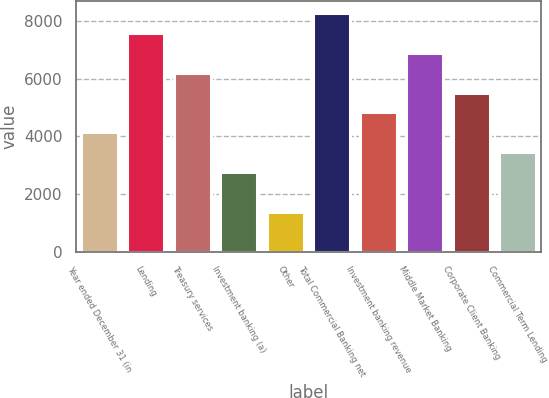Convert chart to OTSL. <chart><loc_0><loc_0><loc_500><loc_500><bar_chart><fcel>Year ended December 31 (in<fcel>Lending<fcel>Treasury services<fcel>Investment banking (a)<fcel>Other<fcel>Total Commercial Banking net<fcel>Investment banking revenue<fcel>Middle Market Banking<fcel>Corporate Client Banking<fcel>Commercial Term Lending<nl><fcel>4137<fcel>7572<fcel>6198<fcel>2763<fcel>1389<fcel>8259<fcel>4824<fcel>6885<fcel>5511<fcel>3450<nl></chart> 